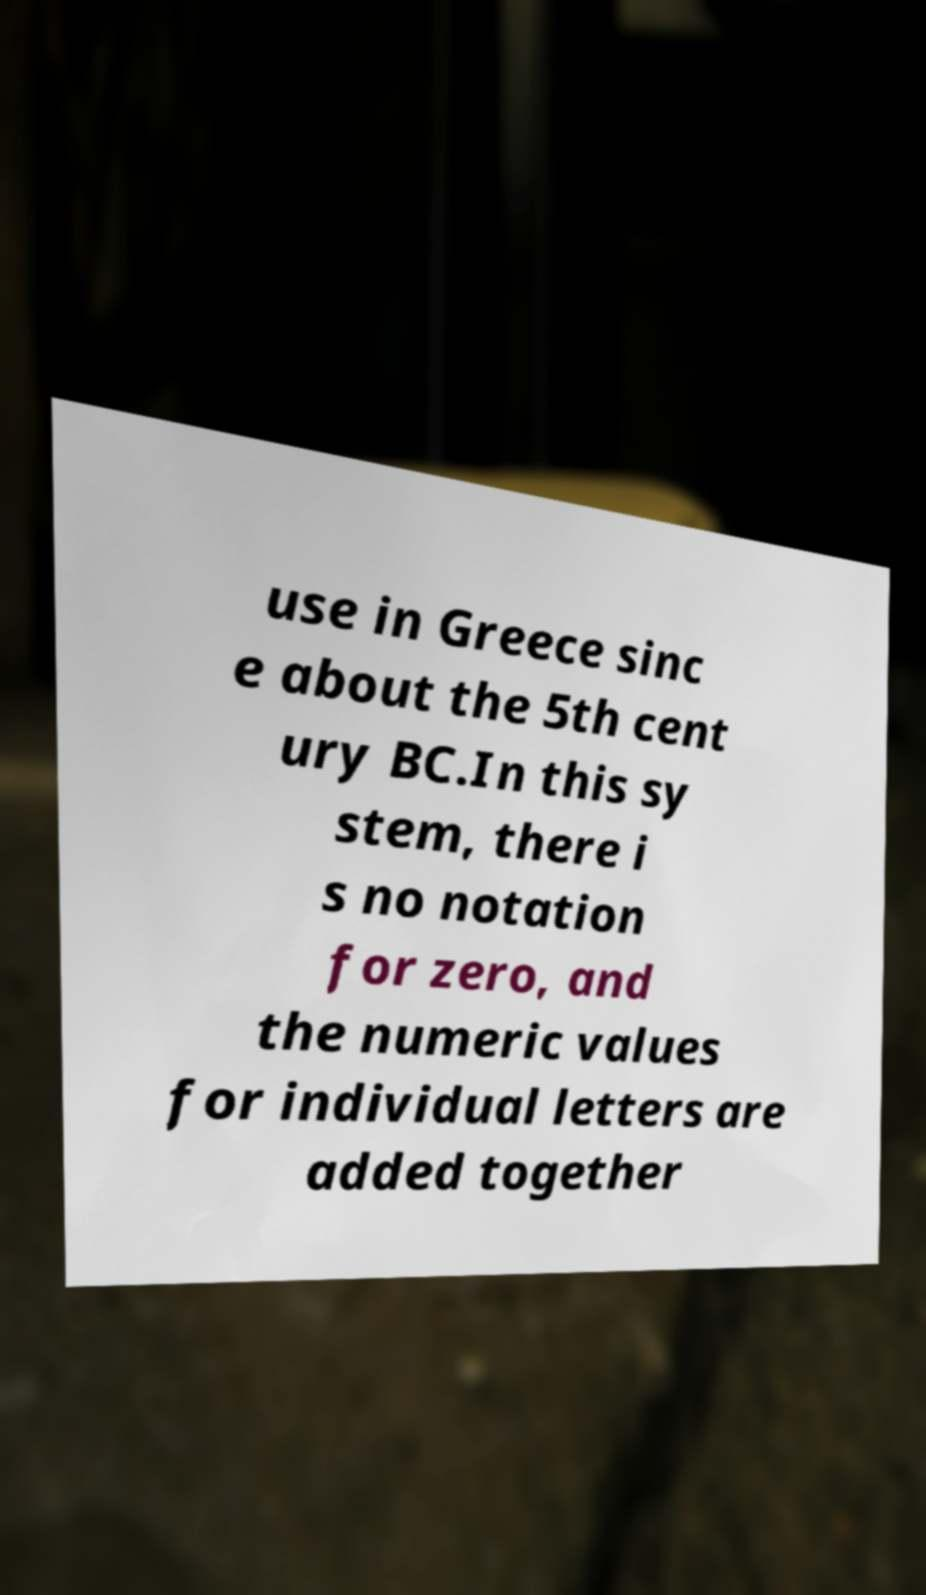Can you accurately transcribe the text from the provided image for me? use in Greece sinc e about the 5th cent ury BC.In this sy stem, there i s no notation for zero, and the numeric values for individual letters are added together 